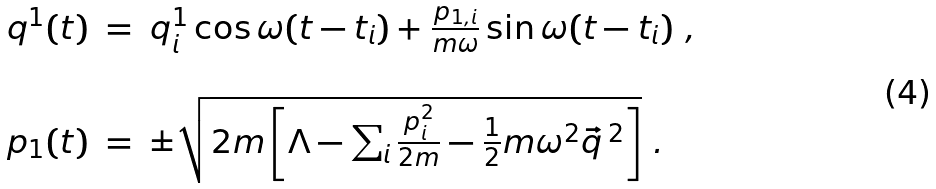<formula> <loc_0><loc_0><loc_500><loc_500>\begin{array} { r c l } q ^ { 1 } ( t ) & = & q ^ { 1 } _ { i } \cos \omega ( t - t _ { i } ) + \frac { p _ { 1 , i } } { m \omega } \sin \omega ( t - t _ { i } ) \ , \\ & & \\ p _ { 1 } ( t ) & = & \pm \sqrt { 2 m \left [ \Lambda - \sum _ { i } \frac { p ^ { 2 } _ { i } } { 2 m } - \frac { 1 } { 2 } m \omega ^ { 2 } \vec { q } \, ^ { 2 } \right ] } \ . \end{array}</formula> 